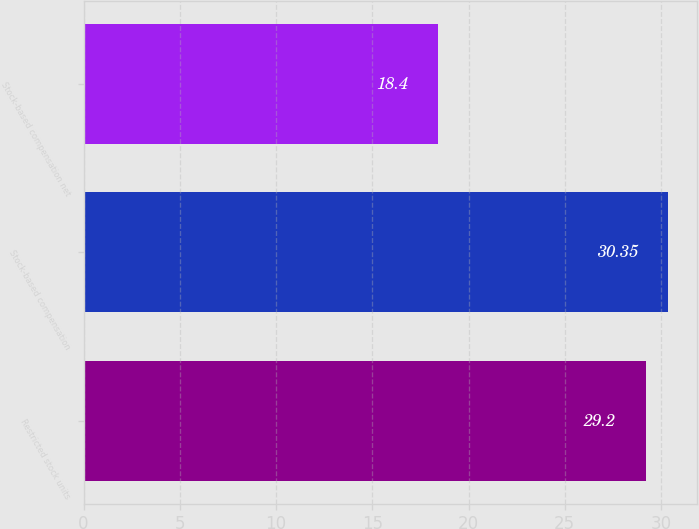Convert chart to OTSL. <chart><loc_0><loc_0><loc_500><loc_500><bar_chart><fcel>Restricted stock units<fcel>Stock-based compensation<fcel>Stock-based compensation net<nl><fcel>29.2<fcel>30.35<fcel>18.4<nl></chart> 